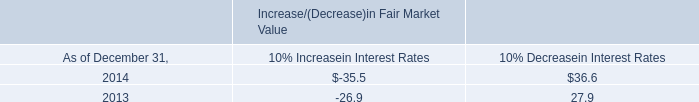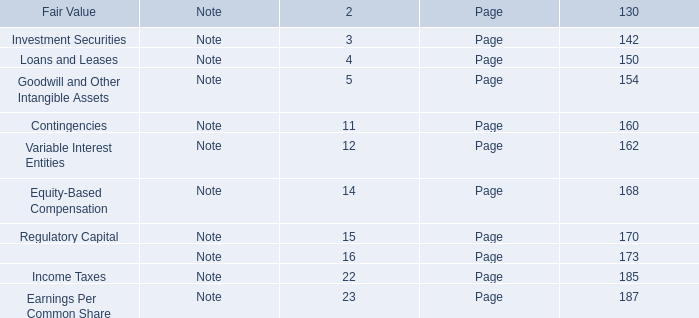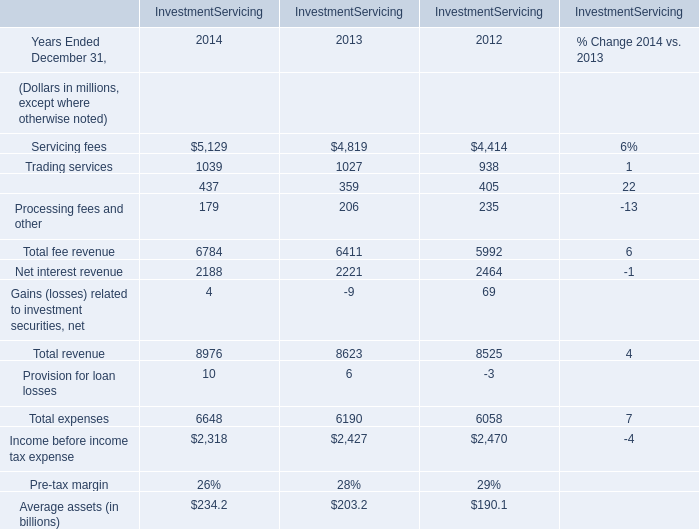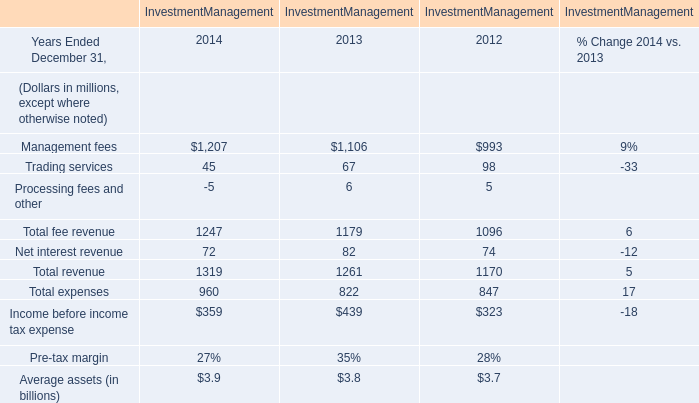what is the average interest income for 2013 and 2014 , in millions? 
Computations: ((27.4 + 24.7) / 2)
Answer: 26.05. 